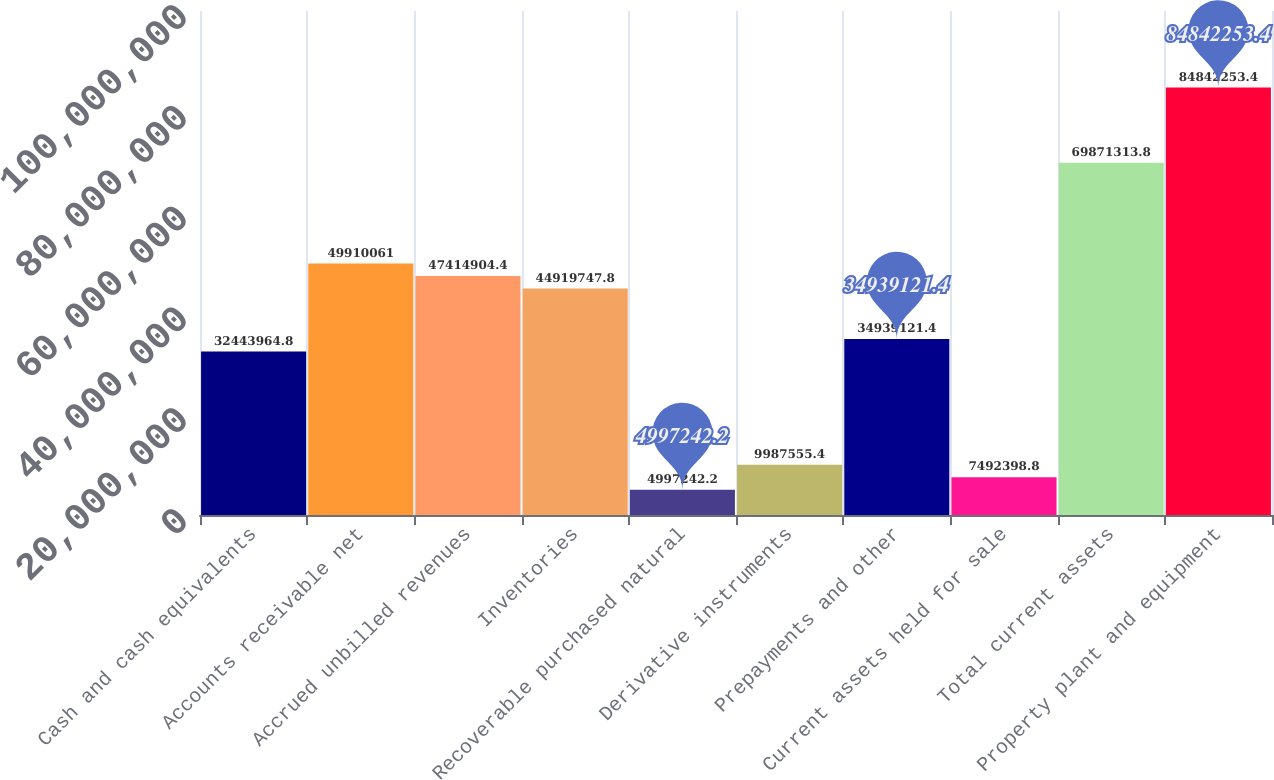Convert chart to OTSL. <chart><loc_0><loc_0><loc_500><loc_500><bar_chart><fcel>Cash and cash equivalents<fcel>Accounts receivable net<fcel>Accrued unbilled revenues<fcel>Inventories<fcel>Recoverable purchased natural<fcel>Derivative instruments<fcel>Prepayments and other<fcel>Current assets held for sale<fcel>Total current assets<fcel>Property plant and equipment<nl><fcel>3.2444e+07<fcel>4.99101e+07<fcel>4.74149e+07<fcel>4.49197e+07<fcel>4.99724e+06<fcel>9.98756e+06<fcel>3.49391e+07<fcel>7.4924e+06<fcel>6.98713e+07<fcel>8.48423e+07<nl></chart> 